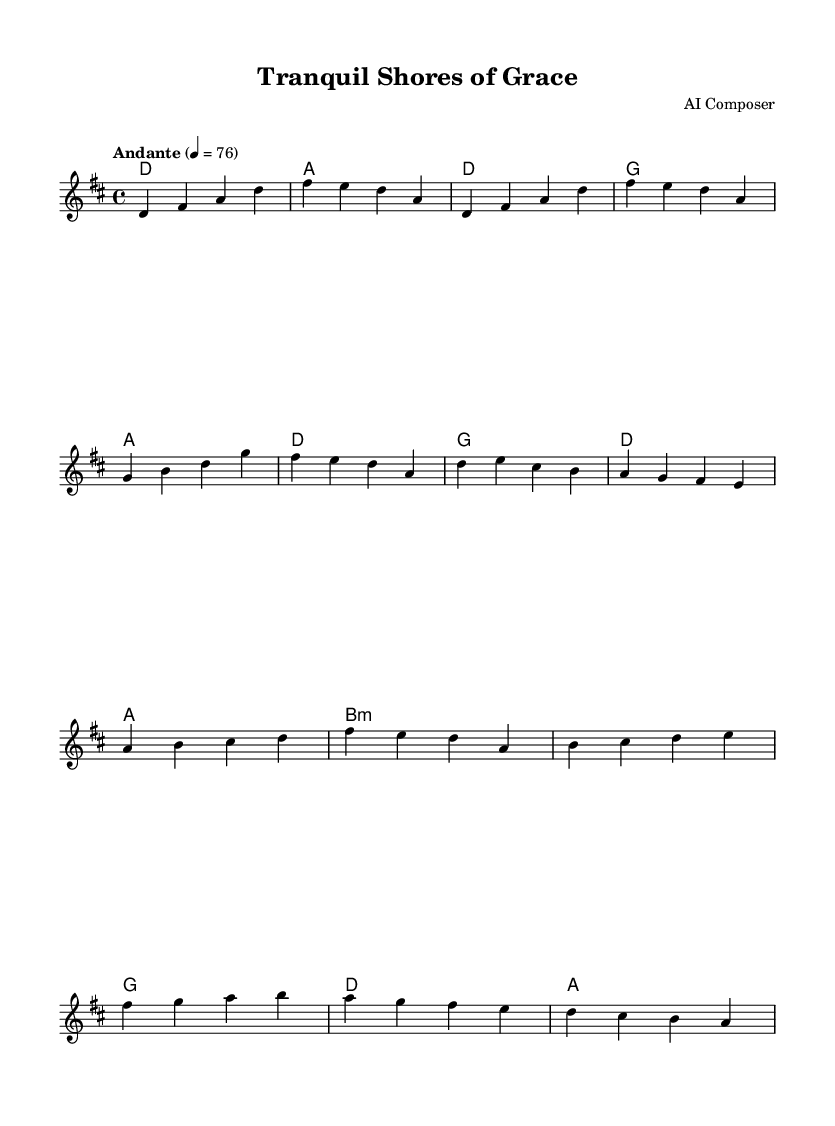What is the key signature of this music? The key signature is D major, which has two sharps: F# and C#. This is indicated at the beginning of the sheet music.
Answer: D major What is the time signature of this music? The time signature is 4/4, which means there are four beats per measure and the quarter note gets one beat. This can be observed at the start of the music.
Answer: 4/4 What is the tempo marking indicated in this music? The tempo marking is Andante, which suggests a moderately slow pace. This is specified above the staff in the tempo directive.
Answer: Andante What chord is played during the chorus starting on the first beat? The first chord played in the chorus is G major, as indicated in the chord symbols above the staff.
Answer: G How does the melody of the bridge compare to the melody of the verse? The melody of the bridge rises and incorporates higher pitches (e.g., starting from b) compared to the verse, which mainly uses middle range pitches. This analysis involves comparing the range of notes and melodic contour in each section.
Answer: Bridge rises How many measures are in the intro section? The intro consists of two measures, as shown by the separation of musical phrases at the start of the piece. Counting the bars completes this observation.
Answer: 2 measures 